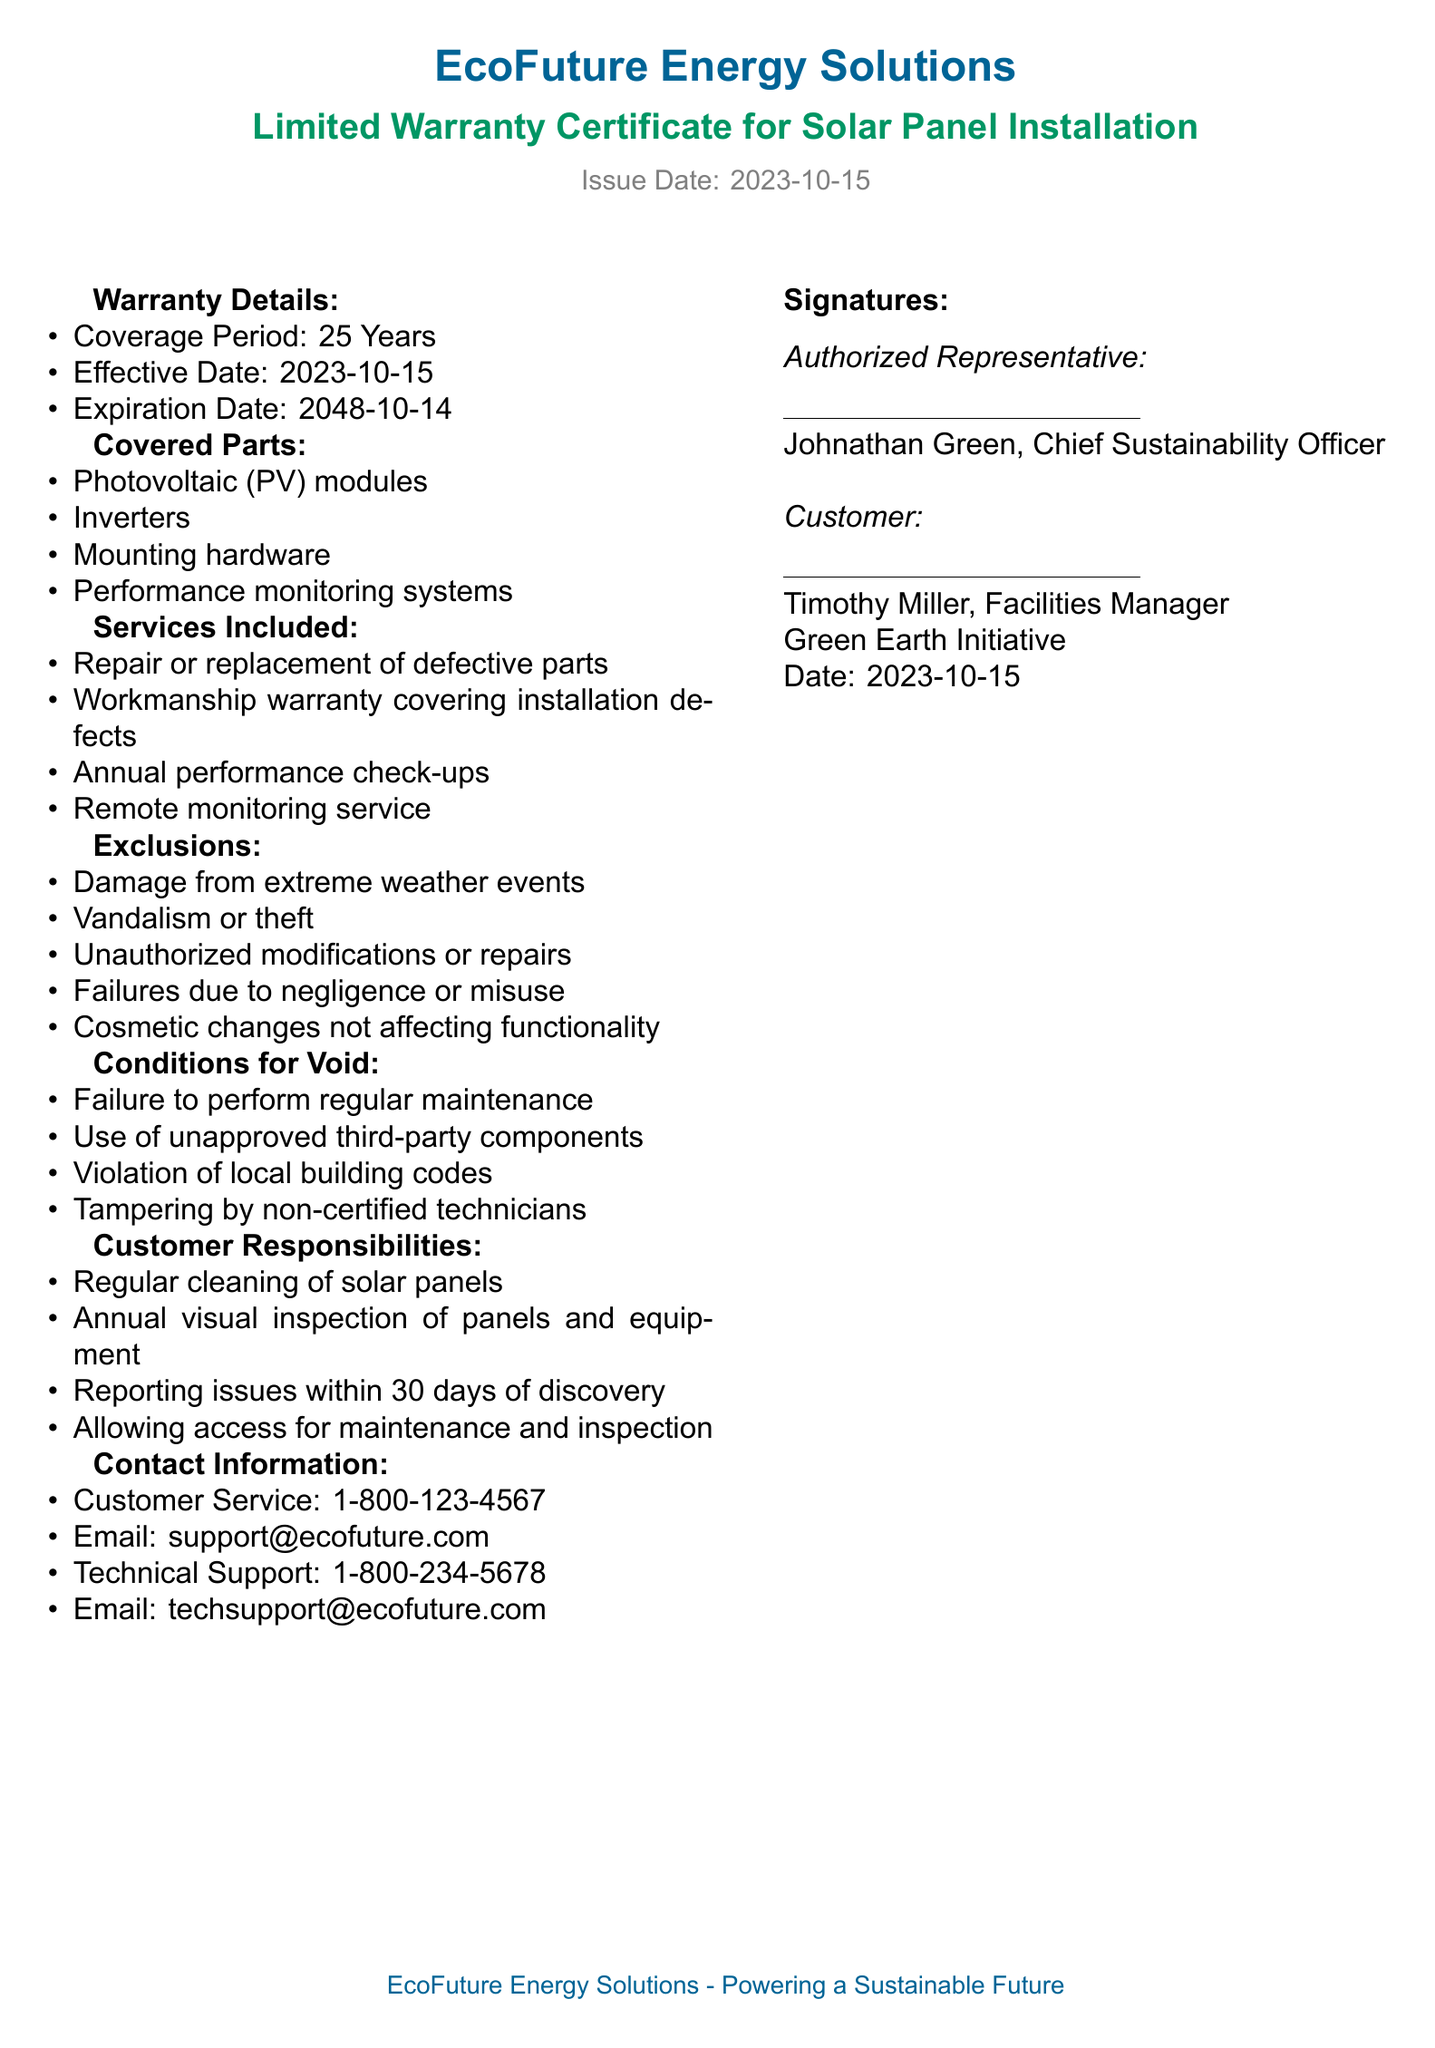What is the coverage period for the warranty? The coverage period for the warranty is stated as 25 Years in the document.
Answer: 25 Years When does the warranty expire? The expiration date is provided as 2048-10-14.
Answer: 2048-10-14 Which parts are covered under this warranty? The document lists covered parts including photovoltaic modules, inverters, mounting hardware, and performance monitoring systems.
Answer: PV modules, inverters, mounting hardware, performance monitoring systems What services are included in the warranty? The warranty includes services such as repair or replacement of defective parts, workmanship warranty, annual performance check-ups, and remote monitoring service.
Answer: Repair or replacement of defective parts, workmanship warranty, annual performance check-ups, remote monitoring service What can void the warranty? Conditions that can void the warranty include failure to perform regular maintenance, use of unapproved third-party components, violation of local building codes, and tampering by non-certified technicians.
Answer: Failure to perform regular maintenance, use of unapproved third-party components, violation of local building codes, tampering by non-certified technicians What must customers do regularly to maintain their warranty? The document states that customers must regularly clean solar panels, conduct annual visual inspections, and report issues within 30 days of discovery.
Answer: Clean solar panels, annual visual inspection, report issues Who signed the warranty as the authorized representative? The authorized representative's signature is under the name Johnathan Green.
Answer: Johnathan Green What is the effective date of the warranty? The effective date is explicitly mentioned in the warranty as 2023-10-15.
Answer: 2023-10-15 How can customers contact technical support? The document provides a technical support phone number and email for customer inquiries.
Answer: 1-800-234-5678, techsupport@ecofuture.com 